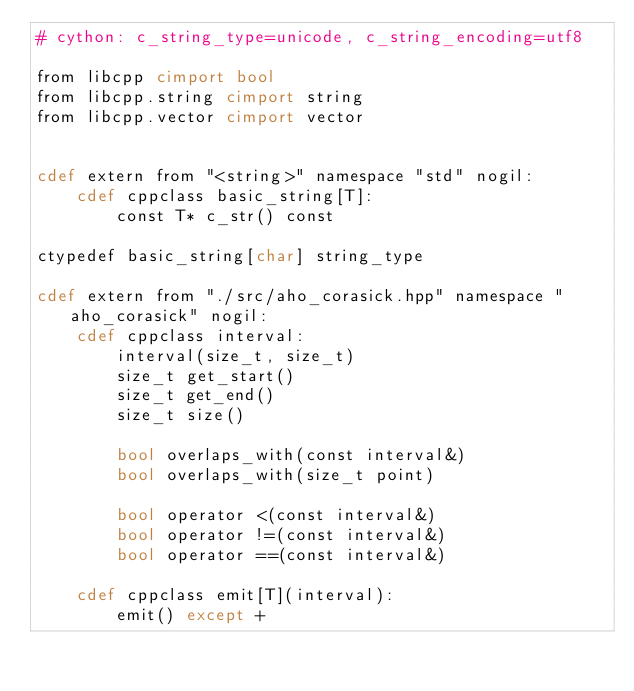<code> <loc_0><loc_0><loc_500><loc_500><_Cython_># cython: c_string_type=unicode, c_string_encoding=utf8

from libcpp cimport bool
from libcpp.string cimport string
from libcpp.vector cimport vector


cdef extern from "<string>" namespace "std" nogil:
    cdef cppclass basic_string[T]:
        const T* c_str() const

ctypedef basic_string[char] string_type

cdef extern from "./src/aho_corasick.hpp" namespace "aho_corasick" nogil:
    cdef cppclass interval:
        interval(size_t, size_t)
        size_t get_start()
        size_t get_end()
        size_t size()

        bool overlaps_with(const interval&)
        bool overlaps_with(size_t point)

        bool operator <(const interval&)
        bool operator !=(const interval&)
        bool operator ==(const interval&)
    
    cdef cppclass emit[T](interval):
        emit() except +</code> 